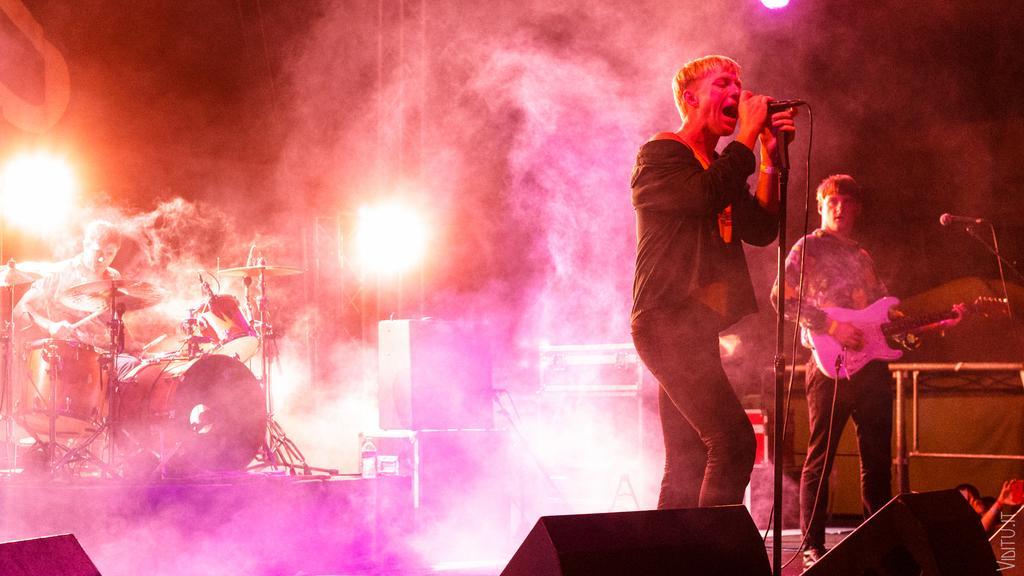How would you summarize this image in a sentence or two? In this picture the whole area is filled with smoke and a black coat guy singing and in the background we observe a guy playing a guitar. In the left side of the image a man sitting and playing the musical instruments. we also observed lights in the background. 